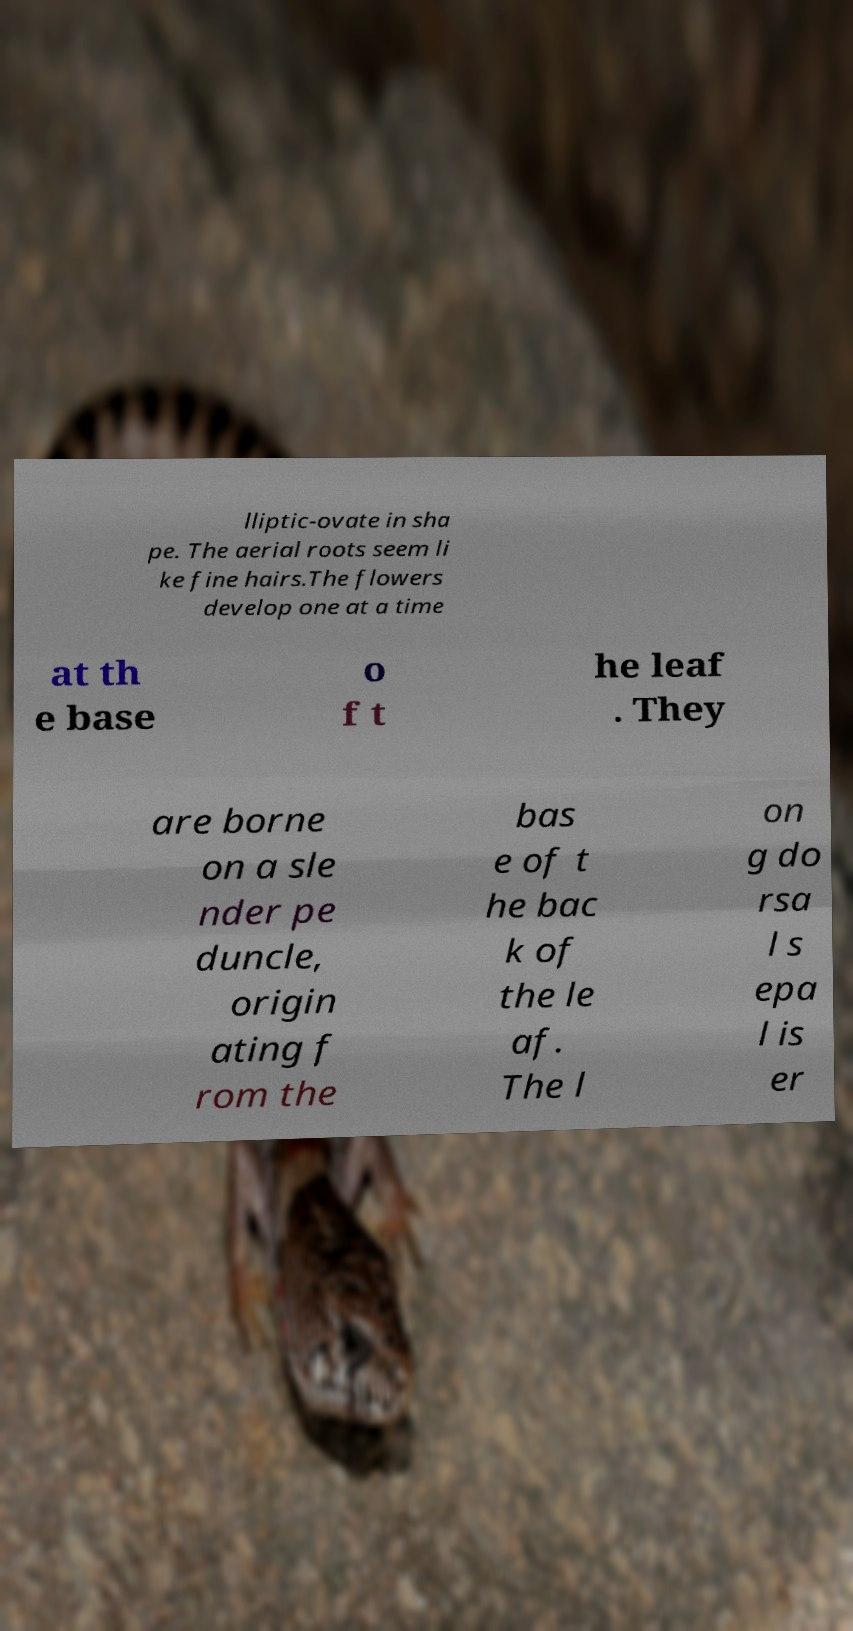What messages or text are displayed in this image? I need them in a readable, typed format. lliptic-ovate in sha pe. The aerial roots seem li ke fine hairs.The flowers develop one at a time at th e base o f t he leaf . They are borne on a sle nder pe duncle, origin ating f rom the bas e of t he bac k of the le af. The l on g do rsa l s epa l is er 